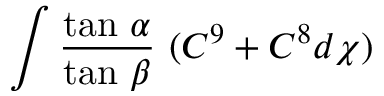<formula> <loc_0><loc_0><loc_500><loc_500>\int \frac { t a n \alpha } { t a n \beta } ( C ^ { 9 } + C ^ { 8 } d \chi )</formula> 